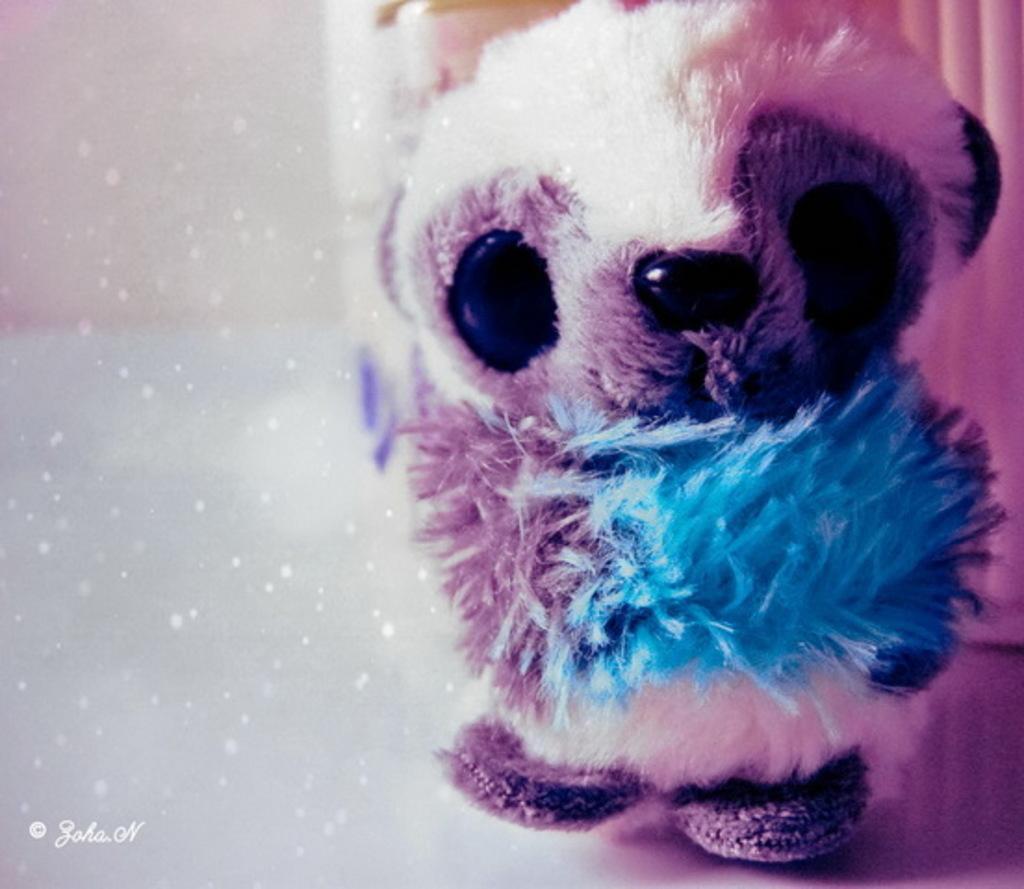Describe this image in one or two sentences. There is a doll. In the background it is blurred. And there is a watermark on the left corner. 